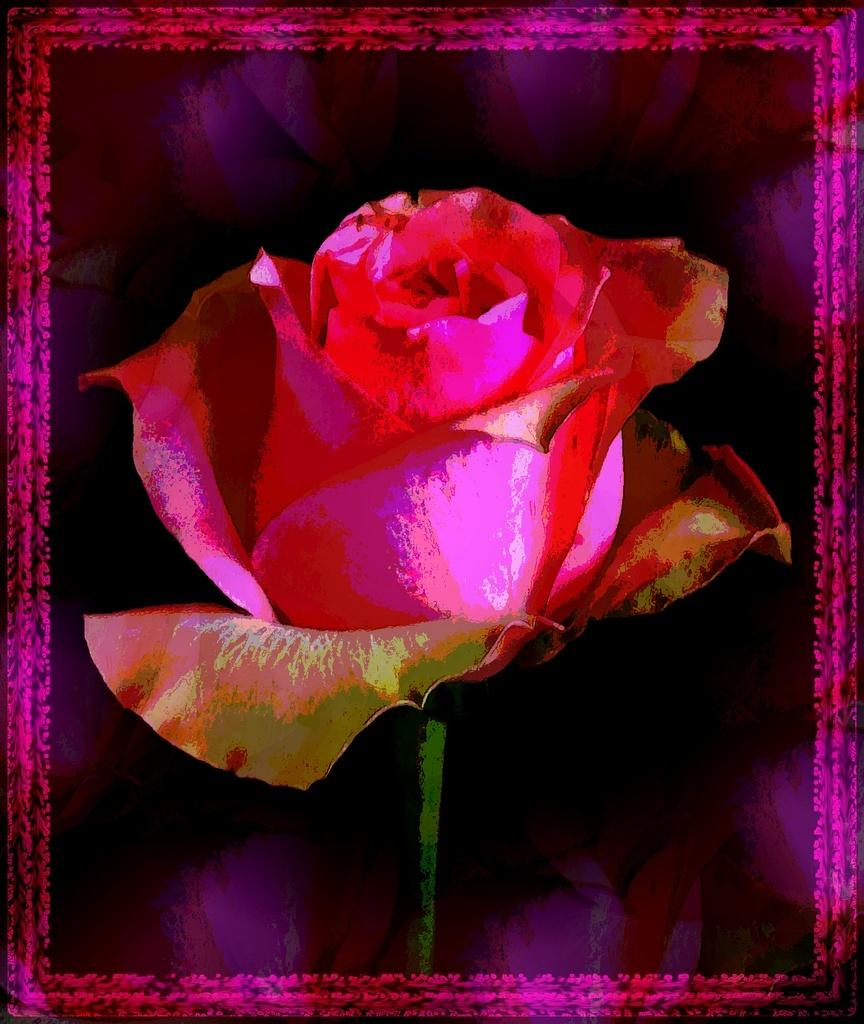What type of flower is in the image? There is a rose flower in the image. Can you describe the rose flower's structure? The rose flower has a stem. How was the image of the rose flower created? The image is an edited picture. What type of kite is flying in the image? There is no kite present in the image; it features a rose flower. Can you tell me how many bones are visible in the image? There are no bones visible in the image; it features a rose flower. 